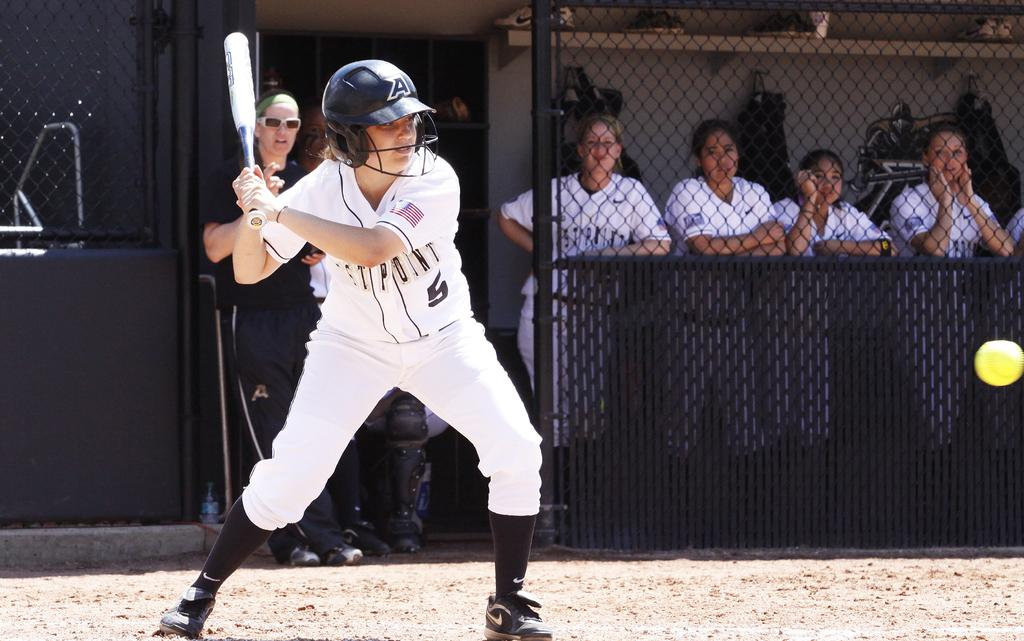Provide a one-sentence caption for the provided image. A girl swings a bat at a softball while wearing a West Point jersey. 